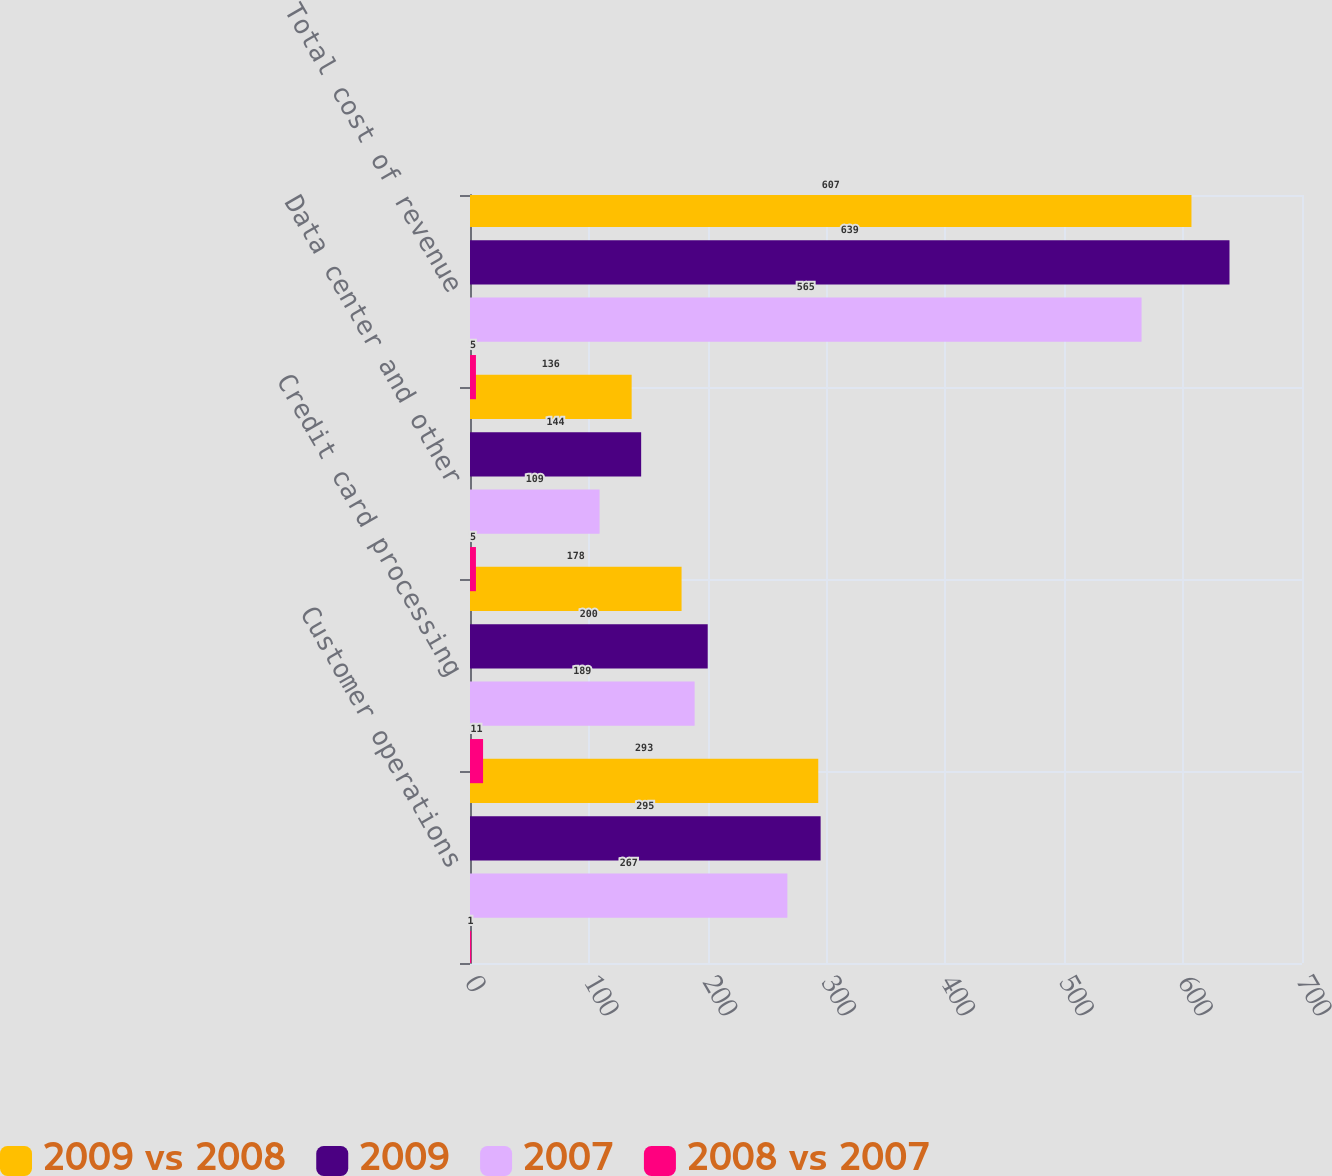<chart> <loc_0><loc_0><loc_500><loc_500><stacked_bar_chart><ecel><fcel>Customer operations<fcel>Credit card processing<fcel>Data center and other<fcel>Total cost of revenue<nl><fcel>2009 vs 2008<fcel>293<fcel>178<fcel>136<fcel>607<nl><fcel>2009<fcel>295<fcel>200<fcel>144<fcel>639<nl><fcel>2007<fcel>267<fcel>189<fcel>109<fcel>565<nl><fcel>2008 vs 2007<fcel>1<fcel>11<fcel>5<fcel>5<nl></chart> 